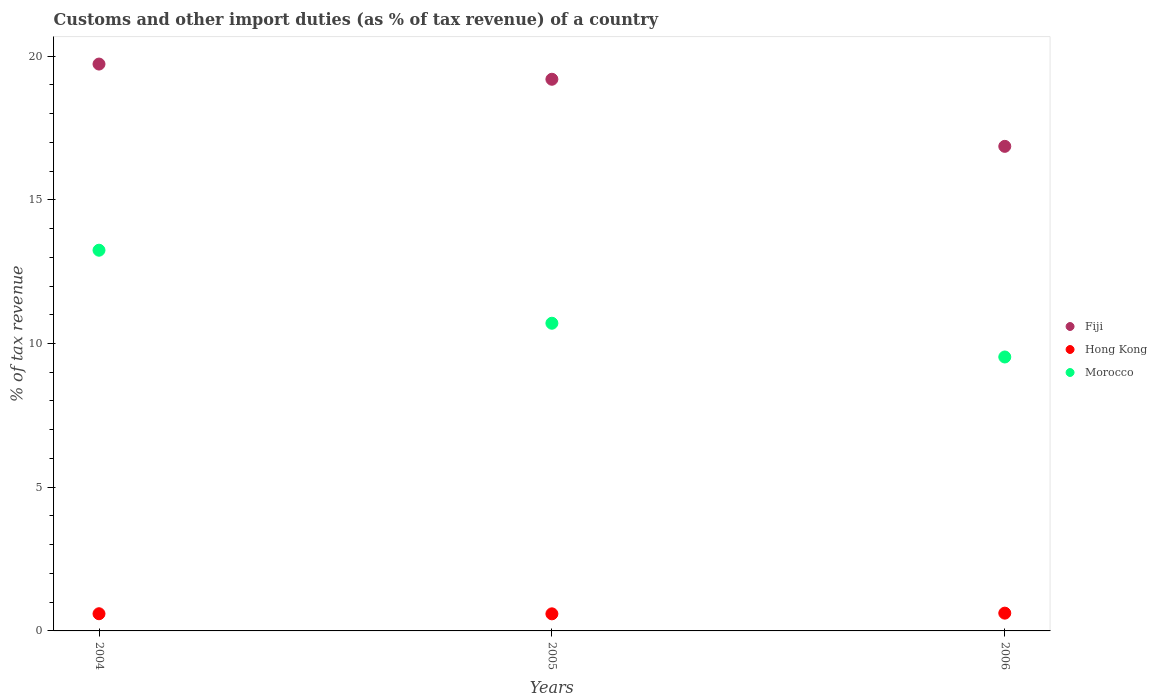Is the number of dotlines equal to the number of legend labels?
Give a very brief answer. Yes. What is the percentage of tax revenue from customs in Morocco in 2006?
Provide a succinct answer. 9.53. Across all years, what is the maximum percentage of tax revenue from customs in Fiji?
Keep it short and to the point. 19.72. Across all years, what is the minimum percentage of tax revenue from customs in Morocco?
Provide a short and direct response. 9.53. In which year was the percentage of tax revenue from customs in Fiji maximum?
Your answer should be compact. 2004. What is the total percentage of tax revenue from customs in Morocco in the graph?
Your answer should be compact. 33.48. What is the difference between the percentage of tax revenue from customs in Fiji in 2004 and that in 2005?
Keep it short and to the point. 0.53. What is the difference between the percentage of tax revenue from customs in Fiji in 2006 and the percentage of tax revenue from customs in Morocco in 2005?
Make the answer very short. 6.15. What is the average percentage of tax revenue from customs in Fiji per year?
Provide a short and direct response. 18.59. In the year 2006, what is the difference between the percentage of tax revenue from customs in Hong Kong and percentage of tax revenue from customs in Fiji?
Make the answer very short. -16.24. What is the ratio of the percentage of tax revenue from customs in Fiji in 2004 to that in 2005?
Give a very brief answer. 1.03. Is the difference between the percentage of tax revenue from customs in Hong Kong in 2004 and 2006 greater than the difference between the percentage of tax revenue from customs in Fiji in 2004 and 2006?
Provide a succinct answer. No. What is the difference between the highest and the second highest percentage of tax revenue from customs in Hong Kong?
Give a very brief answer. 0.02. What is the difference between the highest and the lowest percentage of tax revenue from customs in Fiji?
Provide a succinct answer. 2.86. Is the percentage of tax revenue from customs in Hong Kong strictly greater than the percentage of tax revenue from customs in Morocco over the years?
Your answer should be compact. No. Is the percentage of tax revenue from customs in Morocco strictly less than the percentage of tax revenue from customs in Hong Kong over the years?
Make the answer very short. No. How many years are there in the graph?
Offer a very short reply. 3. What is the difference between two consecutive major ticks on the Y-axis?
Provide a short and direct response. 5. Does the graph contain any zero values?
Provide a succinct answer. No. How many legend labels are there?
Offer a very short reply. 3. How are the legend labels stacked?
Ensure brevity in your answer.  Vertical. What is the title of the graph?
Keep it short and to the point. Customs and other import duties (as % of tax revenue) of a country. Does "Serbia" appear as one of the legend labels in the graph?
Your answer should be compact. No. What is the label or title of the Y-axis?
Your answer should be compact. % of tax revenue. What is the % of tax revenue in Fiji in 2004?
Make the answer very short. 19.72. What is the % of tax revenue in Hong Kong in 2004?
Make the answer very short. 0.6. What is the % of tax revenue in Morocco in 2004?
Give a very brief answer. 13.25. What is the % of tax revenue in Fiji in 2005?
Offer a very short reply. 19.19. What is the % of tax revenue of Hong Kong in 2005?
Give a very brief answer. 0.59. What is the % of tax revenue in Morocco in 2005?
Offer a terse response. 10.71. What is the % of tax revenue in Fiji in 2006?
Your response must be concise. 16.86. What is the % of tax revenue in Hong Kong in 2006?
Provide a short and direct response. 0.62. What is the % of tax revenue in Morocco in 2006?
Provide a succinct answer. 9.53. Across all years, what is the maximum % of tax revenue in Fiji?
Make the answer very short. 19.72. Across all years, what is the maximum % of tax revenue of Hong Kong?
Offer a very short reply. 0.62. Across all years, what is the maximum % of tax revenue of Morocco?
Your answer should be very brief. 13.25. Across all years, what is the minimum % of tax revenue in Fiji?
Give a very brief answer. 16.86. Across all years, what is the minimum % of tax revenue in Hong Kong?
Your answer should be very brief. 0.59. Across all years, what is the minimum % of tax revenue of Morocco?
Give a very brief answer. 9.53. What is the total % of tax revenue of Fiji in the graph?
Offer a terse response. 55.78. What is the total % of tax revenue in Hong Kong in the graph?
Your answer should be compact. 1.81. What is the total % of tax revenue of Morocco in the graph?
Your answer should be very brief. 33.48. What is the difference between the % of tax revenue of Fiji in 2004 and that in 2005?
Offer a terse response. 0.53. What is the difference between the % of tax revenue of Hong Kong in 2004 and that in 2005?
Provide a short and direct response. 0. What is the difference between the % of tax revenue in Morocco in 2004 and that in 2005?
Ensure brevity in your answer.  2.54. What is the difference between the % of tax revenue of Fiji in 2004 and that in 2006?
Give a very brief answer. 2.86. What is the difference between the % of tax revenue in Hong Kong in 2004 and that in 2006?
Offer a very short reply. -0.02. What is the difference between the % of tax revenue in Morocco in 2004 and that in 2006?
Give a very brief answer. 3.71. What is the difference between the % of tax revenue in Fiji in 2005 and that in 2006?
Ensure brevity in your answer.  2.33. What is the difference between the % of tax revenue of Hong Kong in 2005 and that in 2006?
Your answer should be very brief. -0.02. What is the difference between the % of tax revenue in Morocco in 2005 and that in 2006?
Your answer should be very brief. 1.17. What is the difference between the % of tax revenue of Fiji in 2004 and the % of tax revenue of Hong Kong in 2005?
Keep it short and to the point. 19.13. What is the difference between the % of tax revenue of Fiji in 2004 and the % of tax revenue of Morocco in 2005?
Your response must be concise. 9.02. What is the difference between the % of tax revenue in Hong Kong in 2004 and the % of tax revenue in Morocco in 2005?
Offer a very short reply. -10.11. What is the difference between the % of tax revenue of Fiji in 2004 and the % of tax revenue of Hong Kong in 2006?
Provide a short and direct response. 19.1. What is the difference between the % of tax revenue of Fiji in 2004 and the % of tax revenue of Morocco in 2006?
Your response must be concise. 10.19. What is the difference between the % of tax revenue of Hong Kong in 2004 and the % of tax revenue of Morocco in 2006?
Give a very brief answer. -8.93. What is the difference between the % of tax revenue of Fiji in 2005 and the % of tax revenue of Hong Kong in 2006?
Make the answer very short. 18.58. What is the difference between the % of tax revenue of Fiji in 2005 and the % of tax revenue of Morocco in 2006?
Make the answer very short. 9.66. What is the difference between the % of tax revenue of Hong Kong in 2005 and the % of tax revenue of Morocco in 2006?
Give a very brief answer. -8.94. What is the average % of tax revenue in Fiji per year?
Give a very brief answer. 18.59. What is the average % of tax revenue in Hong Kong per year?
Provide a succinct answer. 0.6. What is the average % of tax revenue in Morocco per year?
Your answer should be very brief. 11.16. In the year 2004, what is the difference between the % of tax revenue in Fiji and % of tax revenue in Hong Kong?
Your response must be concise. 19.13. In the year 2004, what is the difference between the % of tax revenue in Fiji and % of tax revenue in Morocco?
Give a very brief answer. 6.48. In the year 2004, what is the difference between the % of tax revenue of Hong Kong and % of tax revenue of Morocco?
Offer a terse response. -12.65. In the year 2005, what is the difference between the % of tax revenue of Fiji and % of tax revenue of Hong Kong?
Ensure brevity in your answer.  18.6. In the year 2005, what is the difference between the % of tax revenue in Fiji and % of tax revenue in Morocco?
Give a very brief answer. 8.49. In the year 2005, what is the difference between the % of tax revenue in Hong Kong and % of tax revenue in Morocco?
Your response must be concise. -10.11. In the year 2006, what is the difference between the % of tax revenue in Fiji and % of tax revenue in Hong Kong?
Your answer should be very brief. 16.24. In the year 2006, what is the difference between the % of tax revenue of Fiji and % of tax revenue of Morocco?
Provide a short and direct response. 7.33. In the year 2006, what is the difference between the % of tax revenue in Hong Kong and % of tax revenue in Morocco?
Provide a short and direct response. -8.91. What is the ratio of the % of tax revenue in Fiji in 2004 to that in 2005?
Give a very brief answer. 1.03. What is the ratio of the % of tax revenue of Hong Kong in 2004 to that in 2005?
Provide a succinct answer. 1.01. What is the ratio of the % of tax revenue in Morocco in 2004 to that in 2005?
Make the answer very short. 1.24. What is the ratio of the % of tax revenue of Fiji in 2004 to that in 2006?
Offer a very short reply. 1.17. What is the ratio of the % of tax revenue of Hong Kong in 2004 to that in 2006?
Offer a terse response. 0.97. What is the ratio of the % of tax revenue of Morocco in 2004 to that in 2006?
Make the answer very short. 1.39. What is the ratio of the % of tax revenue in Fiji in 2005 to that in 2006?
Your response must be concise. 1.14. What is the ratio of the % of tax revenue of Hong Kong in 2005 to that in 2006?
Give a very brief answer. 0.96. What is the ratio of the % of tax revenue of Morocco in 2005 to that in 2006?
Make the answer very short. 1.12. What is the difference between the highest and the second highest % of tax revenue in Fiji?
Your answer should be compact. 0.53. What is the difference between the highest and the second highest % of tax revenue in Hong Kong?
Provide a short and direct response. 0.02. What is the difference between the highest and the second highest % of tax revenue in Morocco?
Keep it short and to the point. 2.54. What is the difference between the highest and the lowest % of tax revenue in Fiji?
Provide a succinct answer. 2.86. What is the difference between the highest and the lowest % of tax revenue of Hong Kong?
Provide a short and direct response. 0.02. What is the difference between the highest and the lowest % of tax revenue in Morocco?
Make the answer very short. 3.71. 